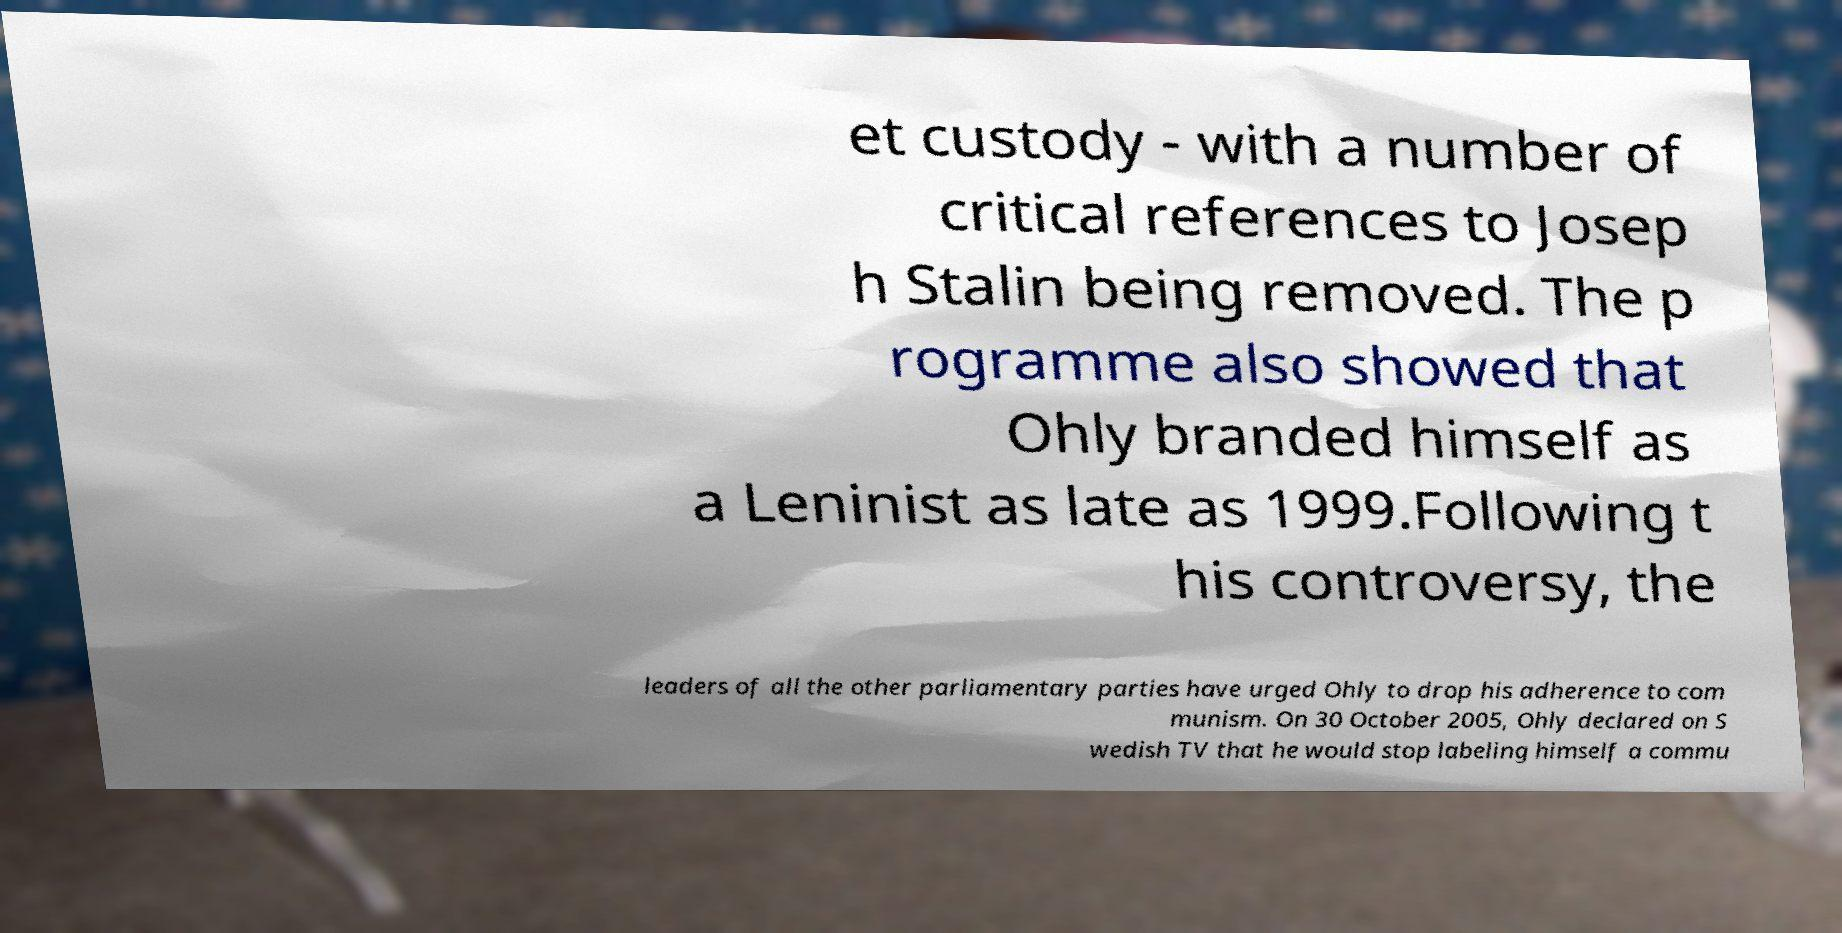Could you extract and type out the text from this image? et custody - with a number of critical references to Josep h Stalin being removed. The p rogramme also showed that Ohly branded himself as a Leninist as late as 1999.Following t his controversy, the leaders of all the other parliamentary parties have urged Ohly to drop his adherence to com munism. On 30 October 2005, Ohly declared on S wedish TV that he would stop labeling himself a commu 